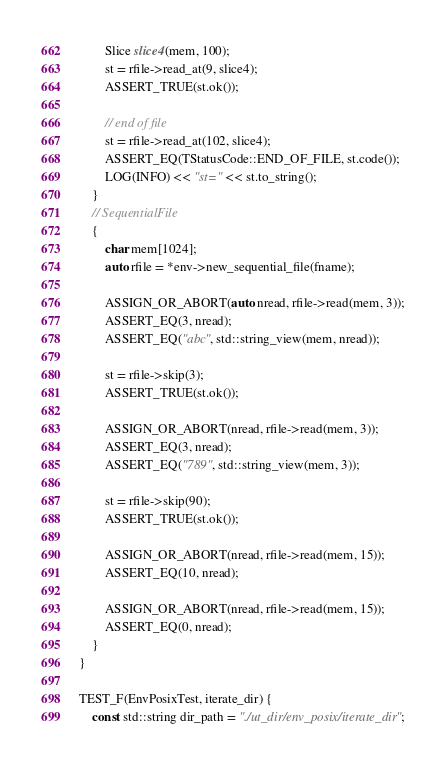Convert code to text. <code><loc_0><loc_0><loc_500><loc_500><_C++_>
        Slice slice4(mem, 100);
        st = rfile->read_at(9, slice4);
        ASSERT_TRUE(st.ok());

        // end of file
        st = rfile->read_at(102, slice4);
        ASSERT_EQ(TStatusCode::END_OF_FILE, st.code());
        LOG(INFO) << "st=" << st.to_string();
    }
    // SequentialFile
    {
        char mem[1024];
        auto rfile = *env->new_sequential_file(fname);

        ASSIGN_OR_ABORT(auto nread, rfile->read(mem, 3));
        ASSERT_EQ(3, nread);
        ASSERT_EQ("abc", std::string_view(mem, nread));

        st = rfile->skip(3);
        ASSERT_TRUE(st.ok());

        ASSIGN_OR_ABORT(nread, rfile->read(mem, 3));
        ASSERT_EQ(3, nread);
        ASSERT_EQ("789", std::string_view(mem, 3));

        st = rfile->skip(90);
        ASSERT_TRUE(st.ok());

        ASSIGN_OR_ABORT(nread, rfile->read(mem, 15));
        ASSERT_EQ(10, nread);

        ASSIGN_OR_ABORT(nread, rfile->read(mem, 15));
        ASSERT_EQ(0, nread);
    }
}

TEST_F(EnvPosixTest, iterate_dir) {
    const std::string dir_path = "./ut_dir/env_posix/iterate_dir";</code> 